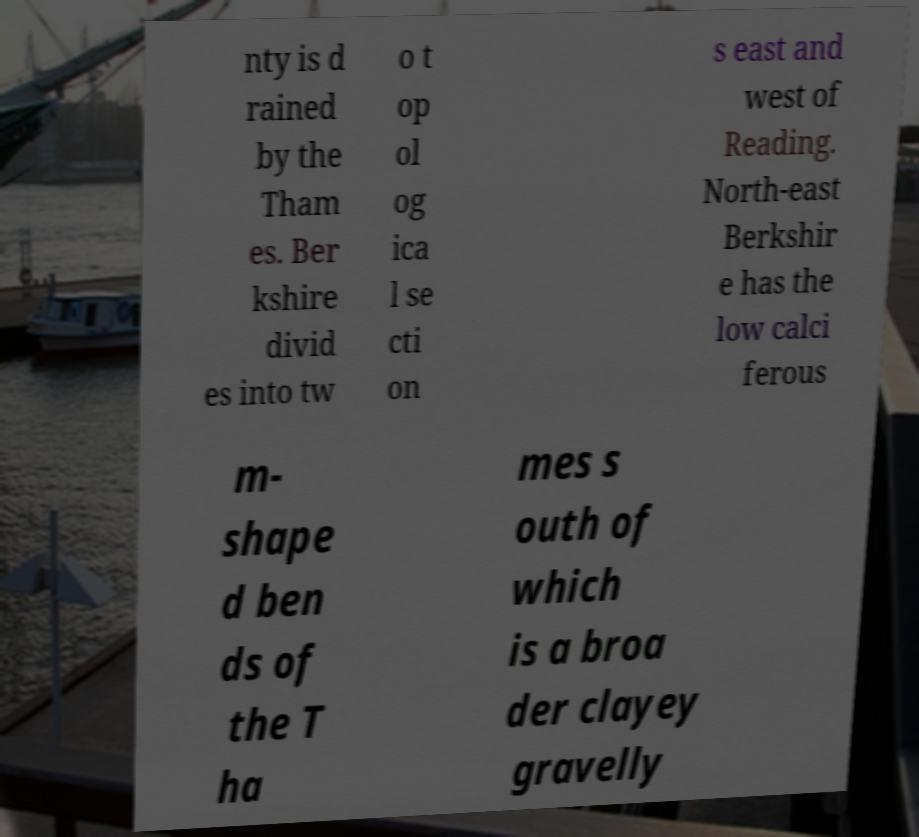Can you read and provide the text displayed in the image?This photo seems to have some interesting text. Can you extract and type it out for me? nty is d rained by the Tham es. Ber kshire divid es into tw o t op ol og ica l se cti on s east and west of Reading. North-east Berkshir e has the low calci ferous m- shape d ben ds of the T ha mes s outh of which is a broa der clayey gravelly 